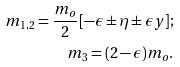<formula> <loc_0><loc_0><loc_500><loc_500>m _ { 1 , 2 } = \frac { m _ { o } } { 2 } [ - \epsilon \pm \eta \pm \epsilon y ] ; \\ m _ { 3 } = ( 2 - \epsilon ) m _ { o } .</formula> 